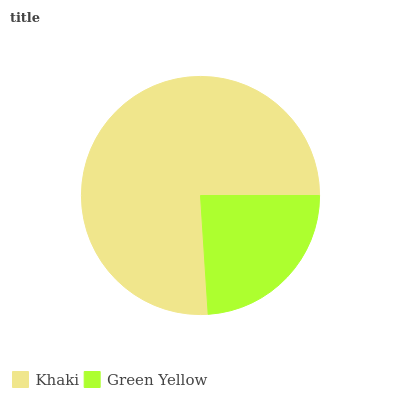Is Green Yellow the minimum?
Answer yes or no. Yes. Is Khaki the maximum?
Answer yes or no. Yes. Is Green Yellow the maximum?
Answer yes or no. No. Is Khaki greater than Green Yellow?
Answer yes or no. Yes. Is Green Yellow less than Khaki?
Answer yes or no. Yes. Is Green Yellow greater than Khaki?
Answer yes or no. No. Is Khaki less than Green Yellow?
Answer yes or no. No. Is Khaki the high median?
Answer yes or no. Yes. Is Green Yellow the low median?
Answer yes or no. Yes. Is Green Yellow the high median?
Answer yes or no. No. Is Khaki the low median?
Answer yes or no. No. 